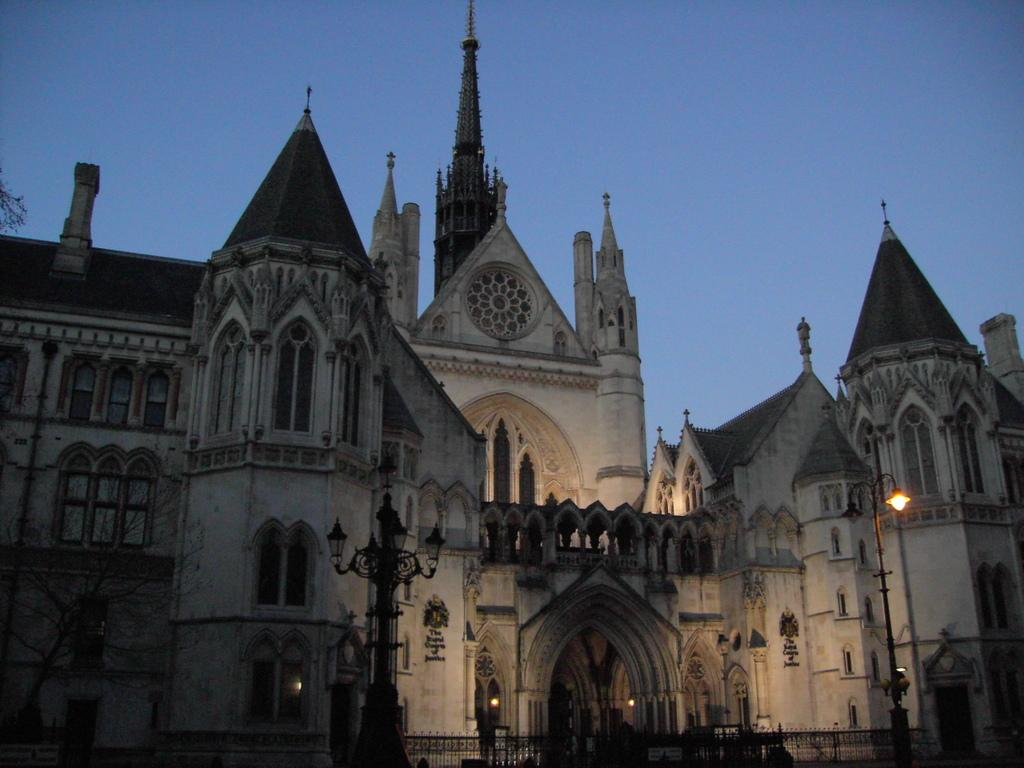What structures can be seen at the front of the image? There are poles in the front of the image. What is located in the center of the image? There is a fence in the center of the image. What type of building is visible in the background of the image? There is a castle in the background of the image. What type of vegetation is on the left side of the image? There is a tree on the left side of the image. Where is the lunchroom located in the image? There is no lunchroom present in the image. In which direction is the castle facing in the image? The direction the castle is facing cannot be determined from the image. 